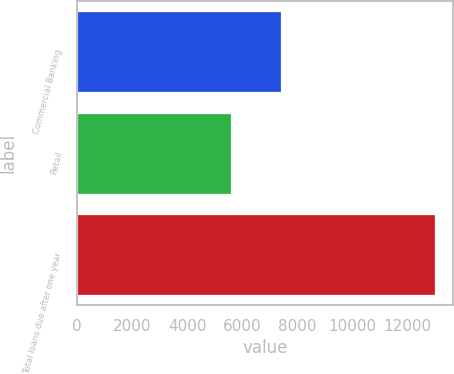<chart> <loc_0><loc_0><loc_500><loc_500><bar_chart><fcel>Commercial Banking<fcel>Retail<fcel>Total loans due after one year<nl><fcel>7407.2<fcel>5576.3<fcel>12983.5<nl></chart> 